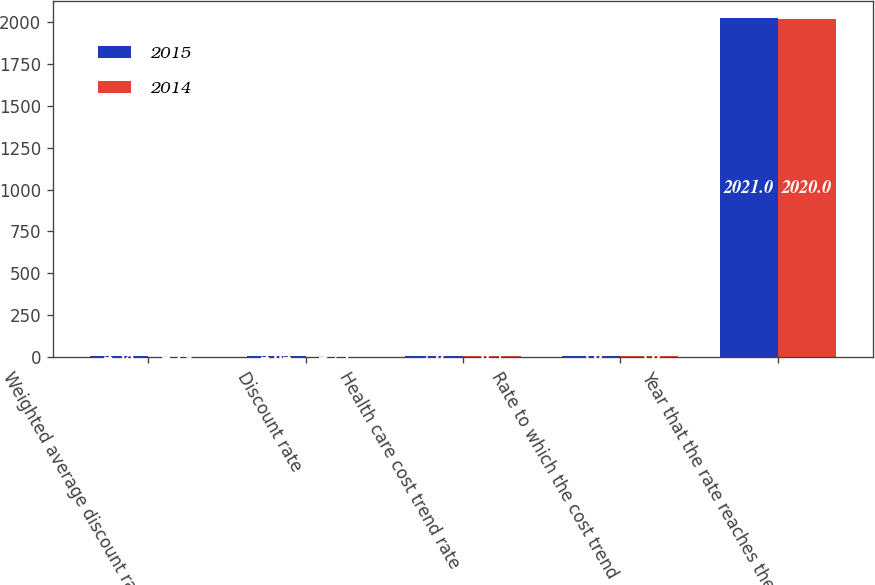<chart> <loc_0><loc_0><loc_500><loc_500><stacked_bar_chart><ecel><fcel>Weighted average discount rate<fcel>Discount rate<fcel>Health care cost trend rate<fcel>Rate to which the cost trend<fcel>Year that the rate reaches the<nl><fcel>2015<fcel>4.58<fcel>4.64<fcel>7<fcel>5<fcel>2021<nl><fcel>2014<fcel>4.19<fcel>4.23<fcel>6.5<fcel>5<fcel>2020<nl></chart> 